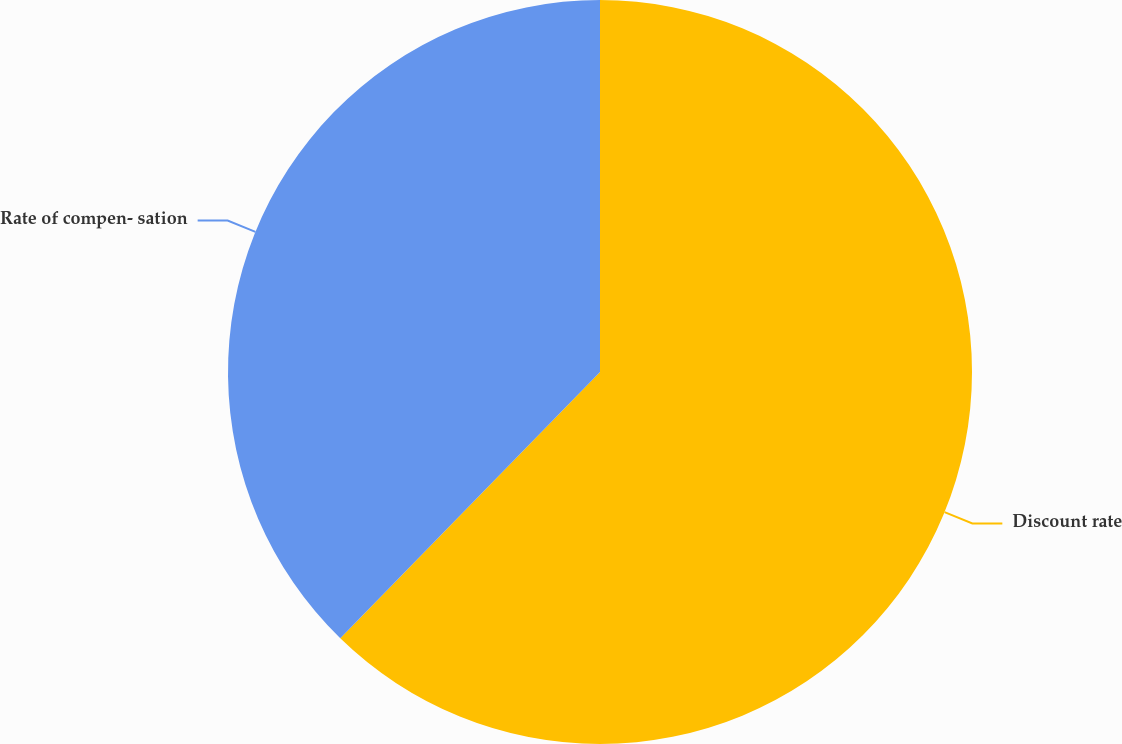Convert chart. <chart><loc_0><loc_0><loc_500><loc_500><pie_chart><fcel>Discount rate<fcel>Rate of compen- sation<nl><fcel>62.3%<fcel>37.7%<nl></chart> 